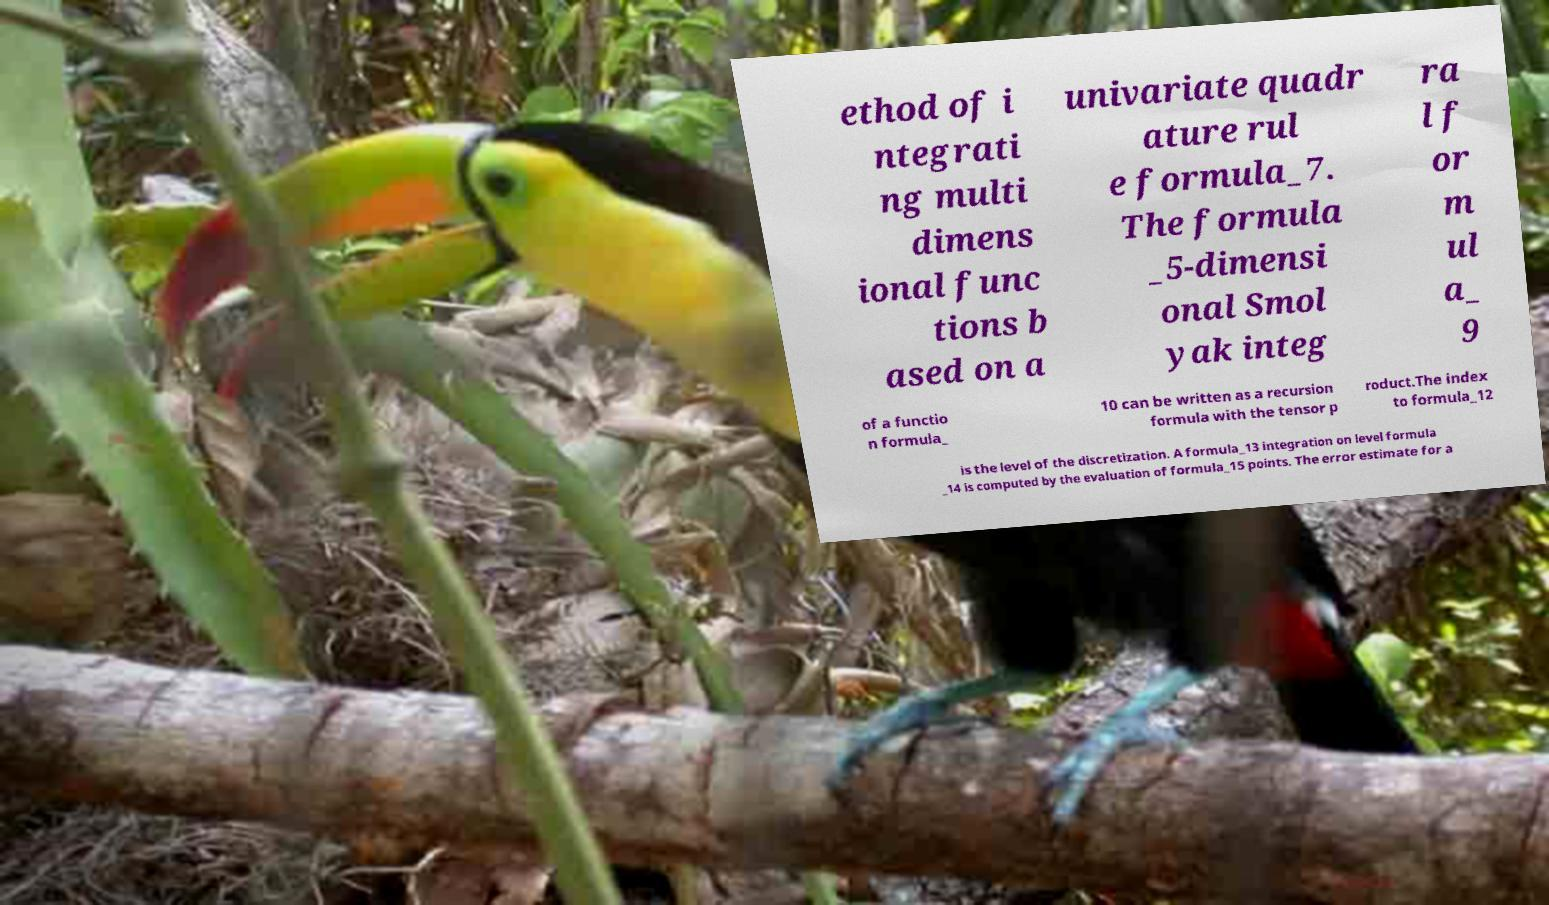Please read and relay the text visible in this image. What does it say? ethod of i ntegrati ng multi dimens ional func tions b ased on a univariate quadr ature rul e formula_7. The formula _5-dimensi onal Smol yak integ ra l f or m ul a_ 9 of a functio n formula_ 10 can be written as a recursion formula with the tensor p roduct.The index to formula_12 is the level of the discretization. A formula_13 integration on level formula _14 is computed by the evaluation of formula_15 points. The error estimate for a 